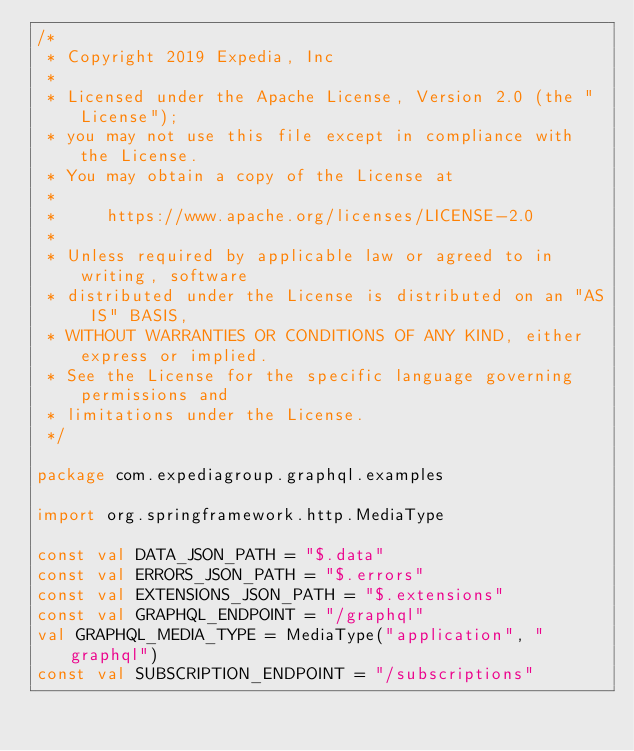<code> <loc_0><loc_0><loc_500><loc_500><_Kotlin_>/*
 * Copyright 2019 Expedia, Inc
 *
 * Licensed under the Apache License, Version 2.0 (the "License");
 * you may not use this file except in compliance with the License.
 * You may obtain a copy of the License at
 *
 *     https://www.apache.org/licenses/LICENSE-2.0
 *
 * Unless required by applicable law or agreed to in writing, software
 * distributed under the License is distributed on an "AS IS" BASIS,
 * WITHOUT WARRANTIES OR CONDITIONS OF ANY KIND, either express or implied.
 * See the License for the specific language governing permissions and
 * limitations under the License.
 */

package com.expediagroup.graphql.examples

import org.springframework.http.MediaType

const val DATA_JSON_PATH = "$.data"
const val ERRORS_JSON_PATH = "$.errors"
const val EXTENSIONS_JSON_PATH = "$.extensions"
const val GRAPHQL_ENDPOINT = "/graphql"
val GRAPHQL_MEDIA_TYPE = MediaType("application", "graphql")
const val SUBSCRIPTION_ENDPOINT = "/subscriptions"
</code> 